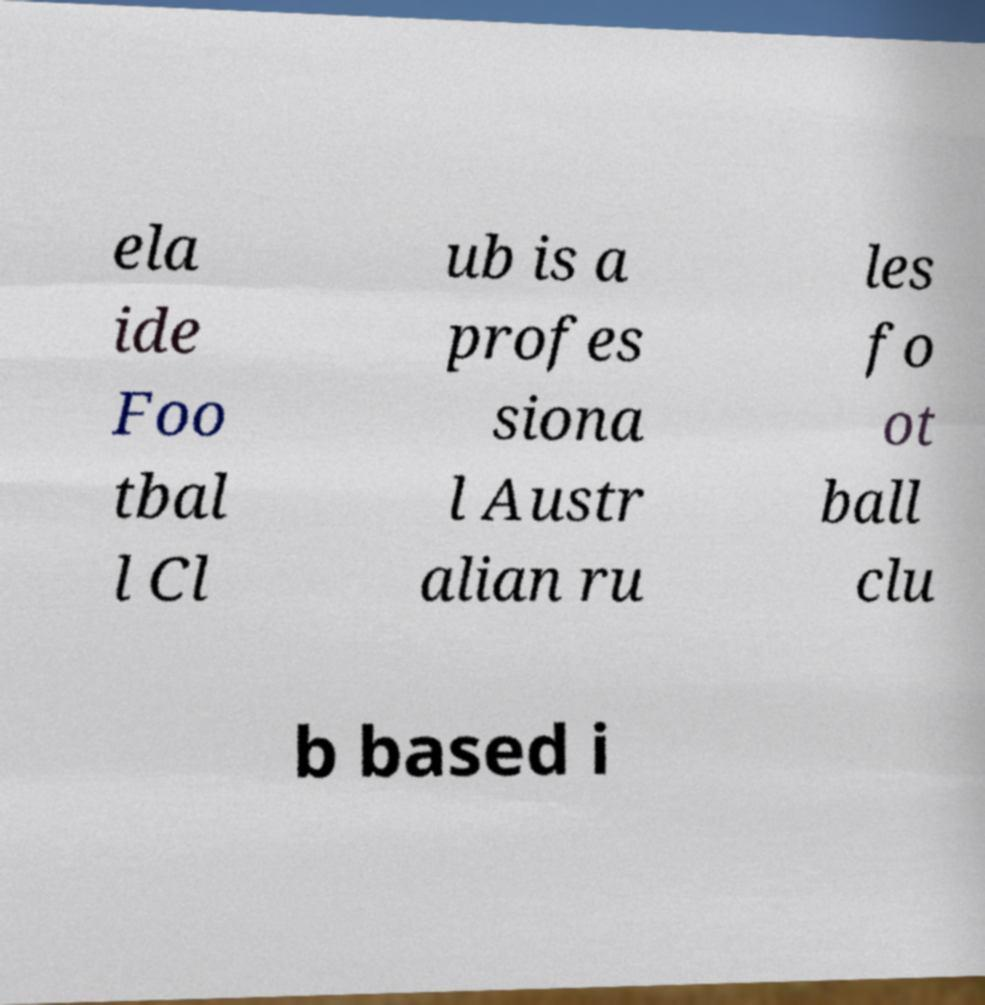Please identify and transcribe the text found in this image. ela ide Foo tbal l Cl ub is a profes siona l Austr alian ru les fo ot ball clu b based i 